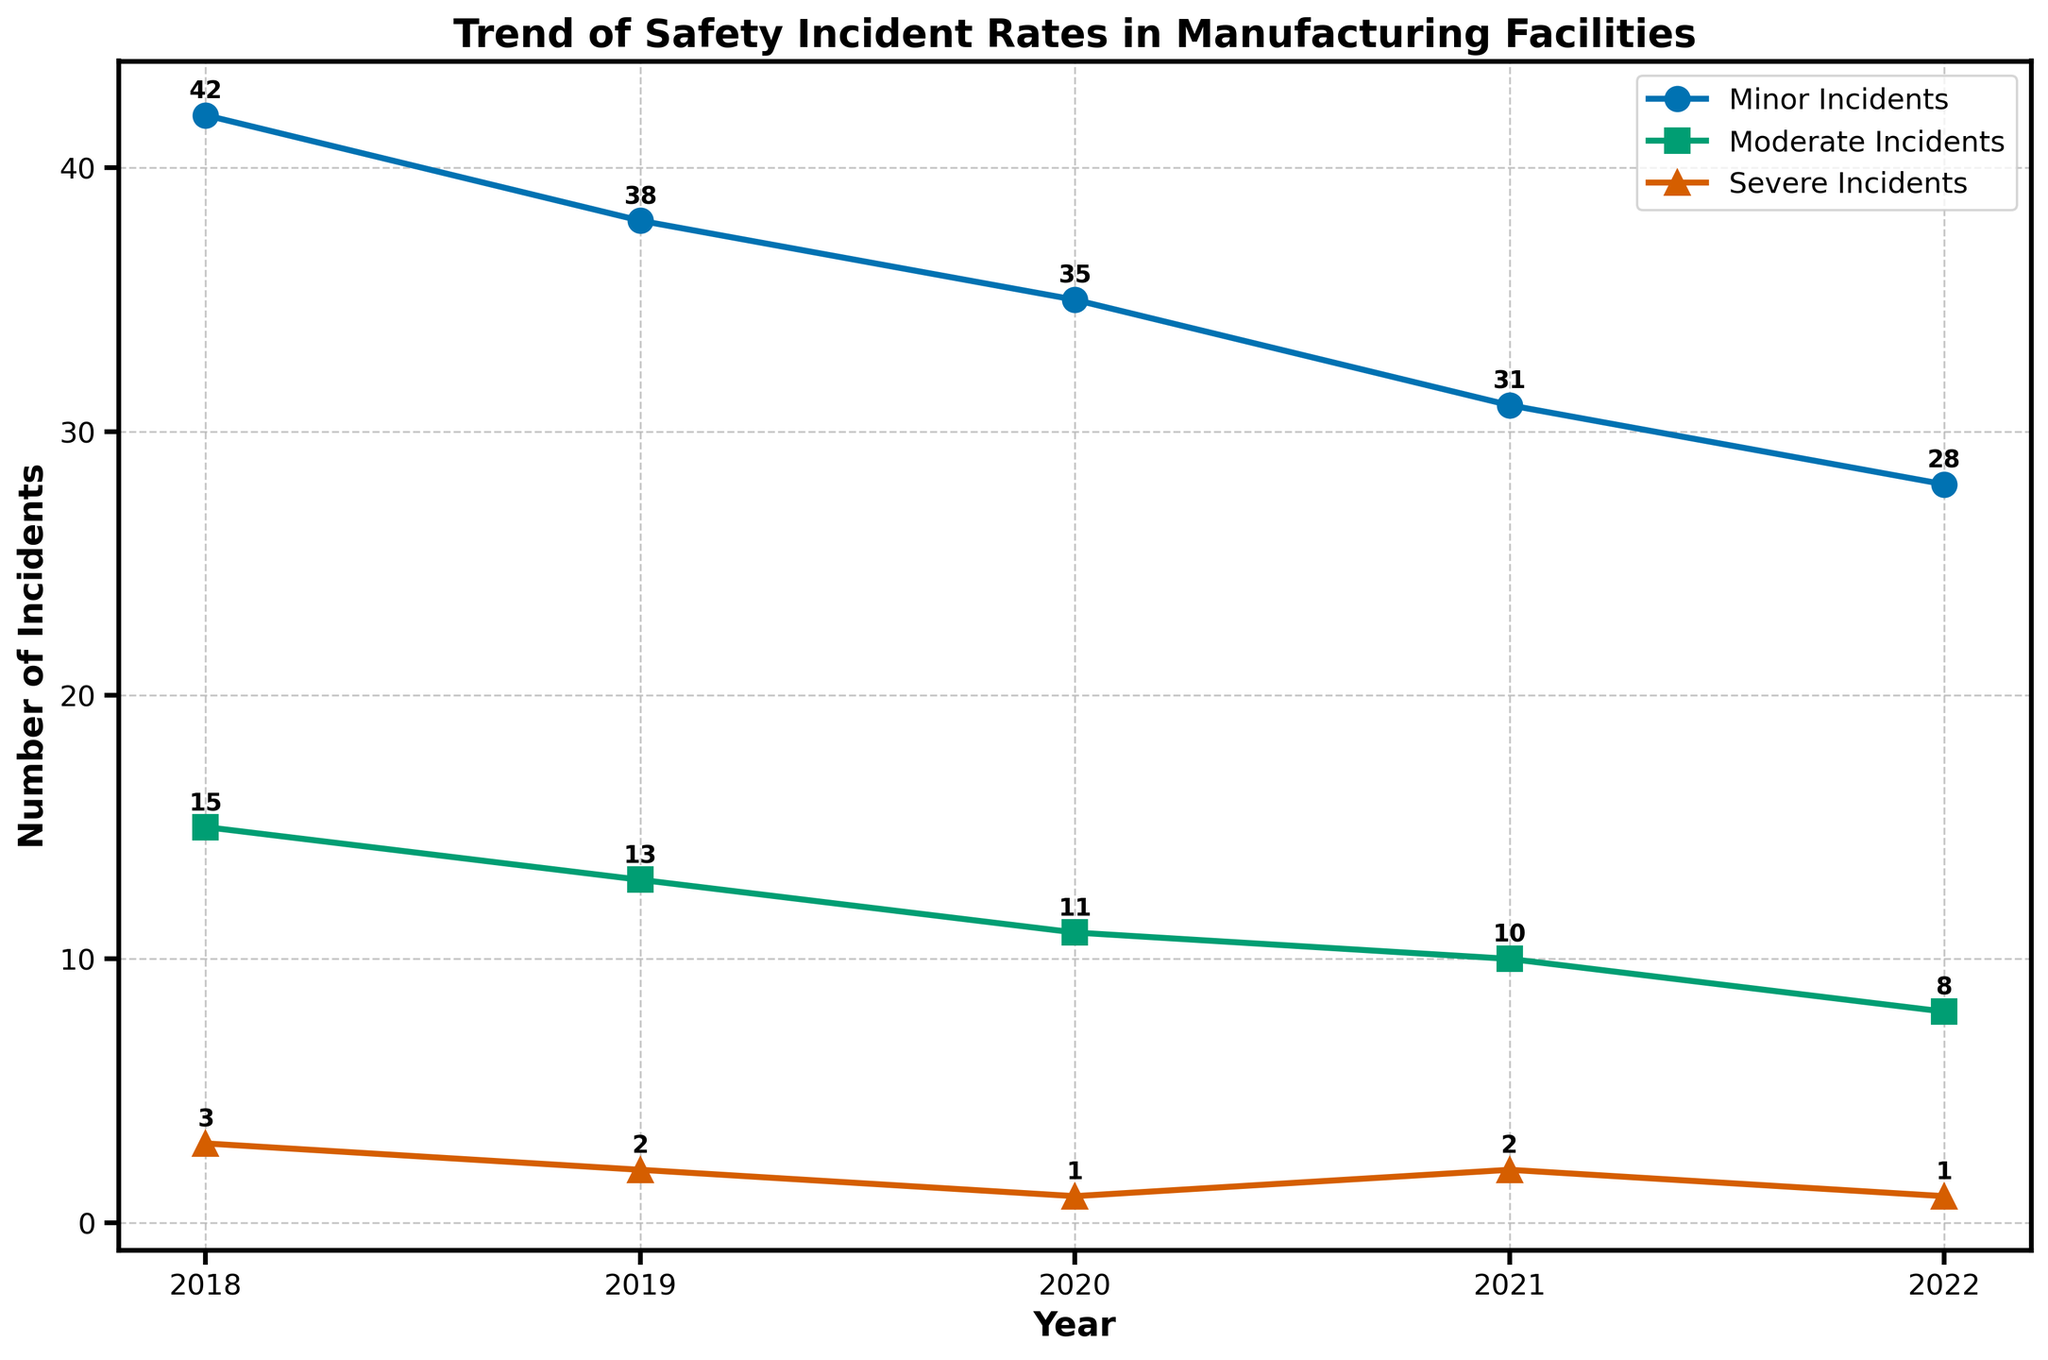What is the overall trend for minor incidents over the 5-year period? The number of minor incidents has been decreasing each year from 42 in 2018 to 28 in 2022.
Answer: Decreasing Which type of incident has experienced the largest decrease over the 5-year period? Both minor incidents and moderate incidents have decreased, but minor incidents have the largest decrease from 42 in 2018 to 28 in 2022, a decrease of 14 incidents.
Answer: Minor Incidents In which year did the severe incidents see a slight increase from the previous year? Severe incidents saw a slight increase from 1 in 2020 to 2 in 2021.
Answer: 2021 How many total incidents were reported in 2021 across all severity levels? Sum the incidents for minor, moderate, and severe in 2021: 31 (minor) + 10 (moderate) + 2 (severe) = 43
Answer: 43 Compare the number of moderate incidents in 2018 and 2022. Which year had more moderate incidents, and by how many? In 2018, there were 15 moderate incidents and in 2022, there were 8. 2018 had more moderate incidents by 15 - 8 = 7 incidents.
Answer: 2018 had more by 7 What is the average number of minor incidents per year over the 5-year period? Sum the number of minor incidents over the 5 years and divide by 5: (42 + 38 + 35 + 31 + 28) / 5 = 34.8
Answer: 34.8 Which severity level had the fewest incidents in 2020? In 2020, the severe incidents were 1, which is fewer than both minor (35) and moderate (11) incidents.
Answer: Severe Incidents How much did the number of severe incidents change between 2019 and 2022? The number of severe incidents in 2019 was 2 and in 2022 was 1. The change is 2 - 1 = 1 incident.
Answer: Decreased by 1 Identify the year with the highest number of combined (minor, moderate, and severe) incidents. Add up all incidents for each year and compare:
- 2018: 42 + 15 + 3 = 60
- 2019: 38 + 13 + 2 = 53
- 2020: 35 + 11 + 1 = 47
- 2021: 31 + 10 + 2 = 43
- 2022: 28 + 8 + 1 = 37
2018 had the highest number of combined incidents with 60.
Answer: 2018 